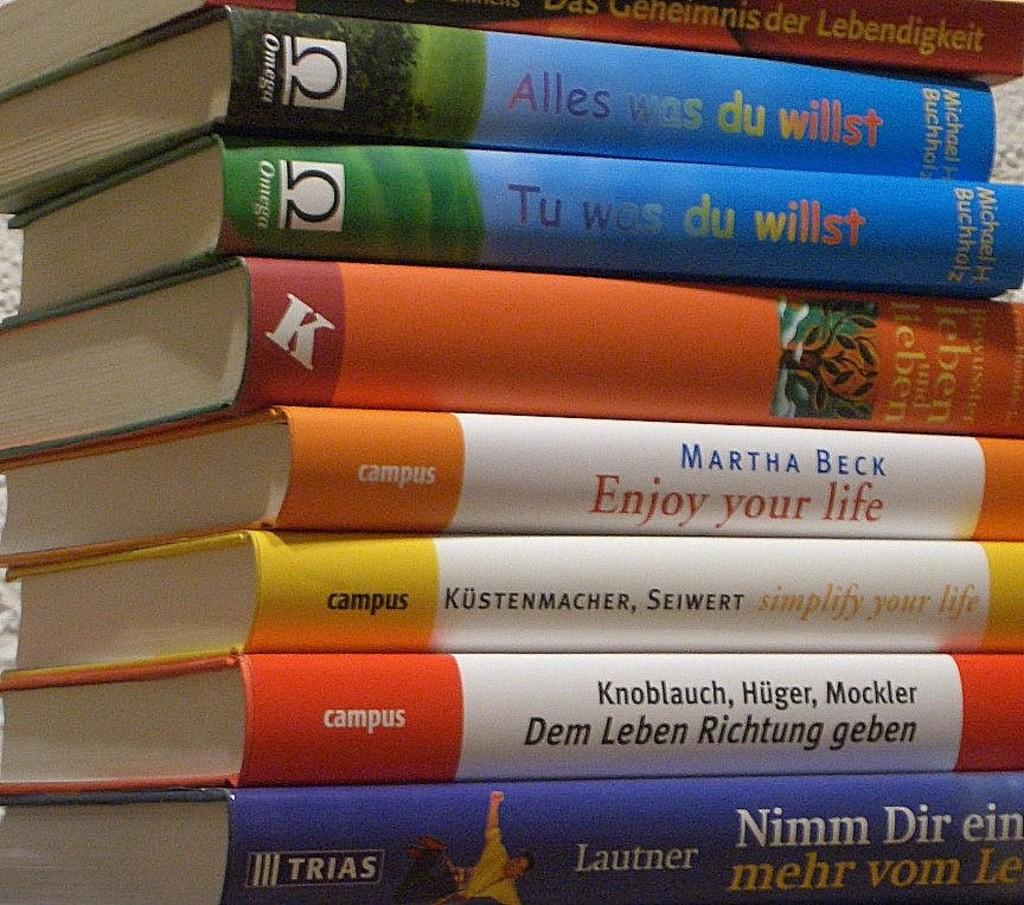<image>
Render a clear and concise summary of the photo. A stack of books including one by Martha Beck titled Enjoy your life. 